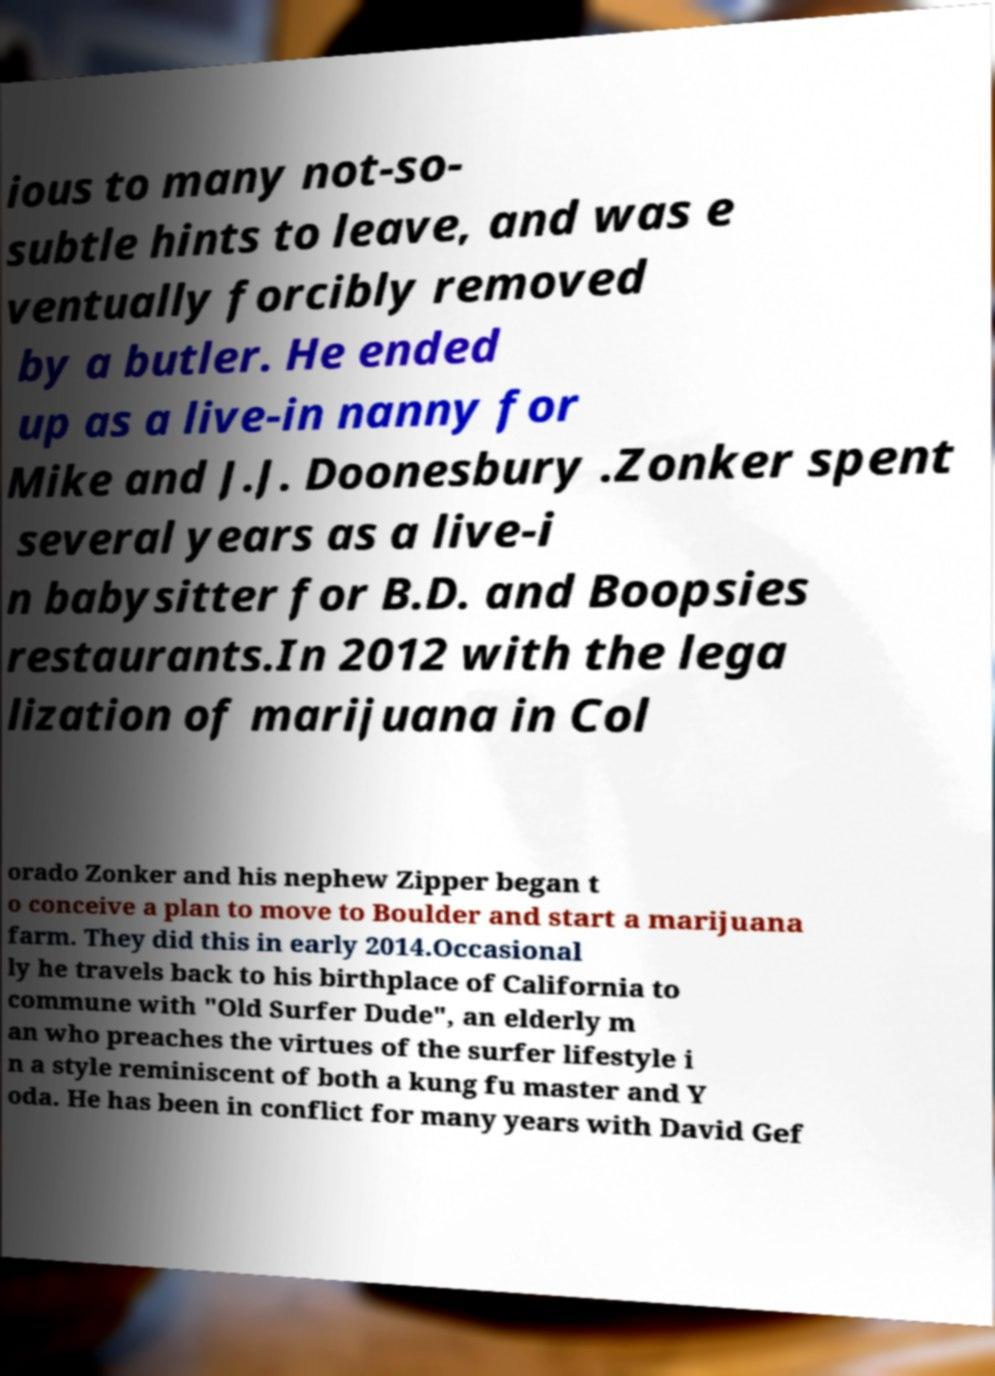There's text embedded in this image that I need extracted. Can you transcribe it verbatim? ious to many not-so- subtle hints to leave, and was e ventually forcibly removed by a butler. He ended up as a live-in nanny for Mike and J.J. Doonesbury .Zonker spent several years as a live-i n babysitter for B.D. and Boopsies restaurants.In 2012 with the lega lization of marijuana in Col orado Zonker and his nephew Zipper began t o conceive a plan to move to Boulder and start a marijuana farm. They did this in early 2014.Occasional ly he travels back to his birthplace of California to commune with "Old Surfer Dude", an elderly m an who preaches the virtues of the surfer lifestyle i n a style reminiscent of both a kung fu master and Y oda. He has been in conflict for many years with David Gef 